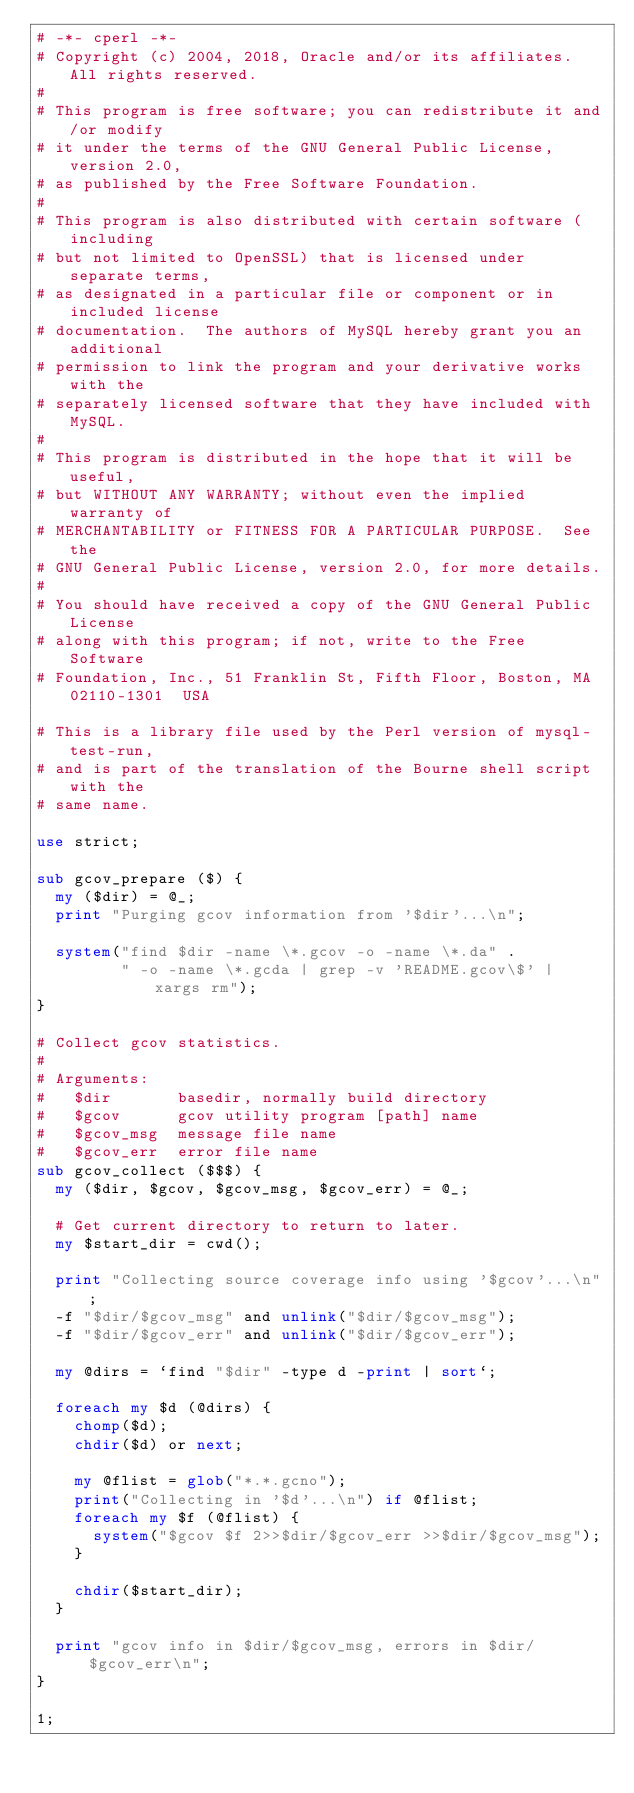<code> <loc_0><loc_0><loc_500><loc_500><_Perl_># -*- cperl -*-
# Copyright (c) 2004, 2018, Oracle and/or its affiliates. All rights reserved.
#
# This program is free software; you can redistribute it and/or modify
# it under the terms of the GNU General Public License, version 2.0,
# as published by the Free Software Foundation.
#
# This program is also distributed with certain software (including
# but not limited to OpenSSL) that is licensed under separate terms,
# as designated in a particular file or component or in included license
# documentation.  The authors of MySQL hereby grant you an additional
# permission to link the program and your derivative works with the
# separately licensed software that they have included with MySQL.
#
# This program is distributed in the hope that it will be useful,
# but WITHOUT ANY WARRANTY; without even the implied warranty of
# MERCHANTABILITY or FITNESS FOR A PARTICULAR PURPOSE.  See the
# GNU General Public License, version 2.0, for more details.
#
# You should have received a copy of the GNU General Public License
# along with this program; if not, write to the Free Software
# Foundation, Inc., 51 Franklin St, Fifth Floor, Boston, MA 02110-1301  USA

# This is a library file used by the Perl version of mysql-test-run,
# and is part of the translation of the Bourne shell script with the
# same name.

use strict;

sub gcov_prepare ($) {
  my ($dir) = @_;
  print "Purging gcov information from '$dir'...\n";

  system("find $dir -name \*.gcov -o -name \*.da" .
         " -o -name \*.gcda | grep -v 'README.gcov\$' | xargs rm");
}

# Collect gcov statistics.
#
# Arguments:
#   $dir       basedir, normally build directory
#   $gcov      gcov utility program [path] name
#   $gcov_msg  message file name
#   $gcov_err  error file name
sub gcov_collect ($$$) {
  my ($dir, $gcov, $gcov_msg, $gcov_err) = @_;

  # Get current directory to return to later.
  my $start_dir = cwd();

  print "Collecting source coverage info using '$gcov'...\n";
  -f "$dir/$gcov_msg" and unlink("$dir/$gcov_msg");
  -f "$dir/$gcov_err" and unlink("$dir/$gcov_err");

  my @dirs = `find "$dir" -type d -print | sort`;

  foreach my $d (@dirs) {
    chomp($d);
    chdir($d) or next;

    my @flist = glob("*.*.gcno");
    print("Collecting in '$d'...\n") if @flist;
    foreach my $f (@flist) {
      system("$gcov $f 2>>$dir/$gcov_err >>$dir/$gcov_msg");
    }

    chdir($start_dir);
  }

  print "gcov info in $dir/$gcov_msg, errors in $dir/$gcov_err\n";
}

1;
</code> 